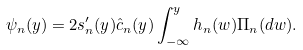Convert formula to latex. <formula><loc_0><loc_0><loc_500><loc_500>\psi _ { n } ( y ) = 2 s ^ { \prime } _ { n } ( y ) \hat { c } _ { n } ( y ) \int _ { - \infty } ^ { y } h _ { n } ( w ) \Pi _ { n } ( d w ) .</formula> 